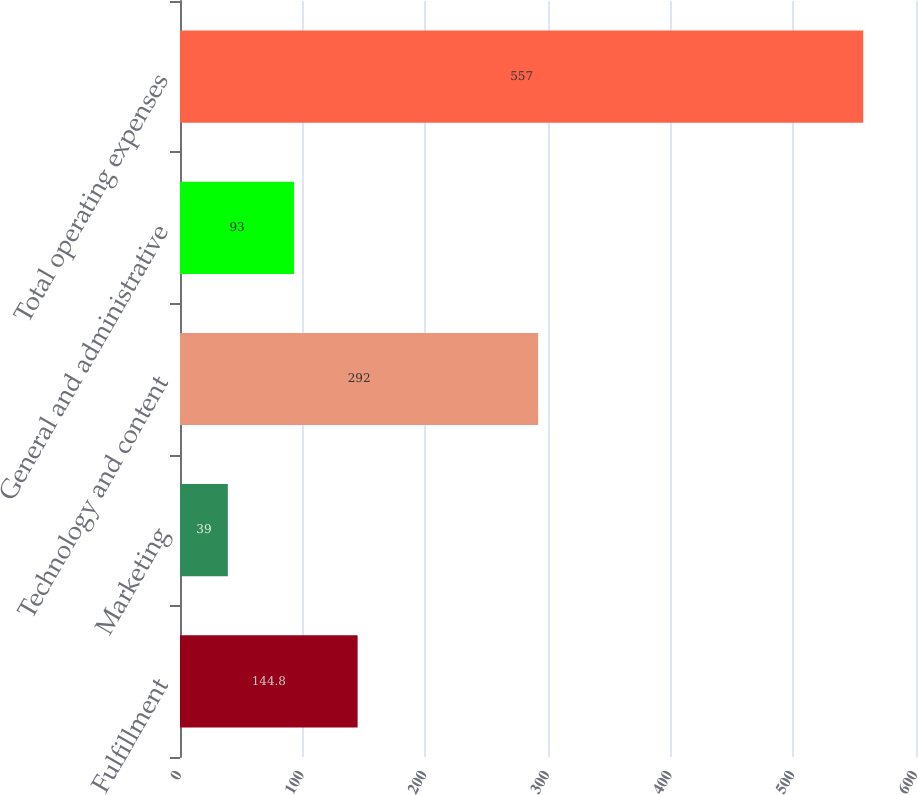Convert chart. <chart><loc_0><loc_0><loc_500><loc_500><bar_chart><fcel>Fulfillment<fcel>Marketing<fcel>Technology and content<fcel>General and administrative<fcel>Total operating expenses<nl><fcel>144.8<fcel>39<fcel>292<fcel>93<fcel>557<nl></chart> 